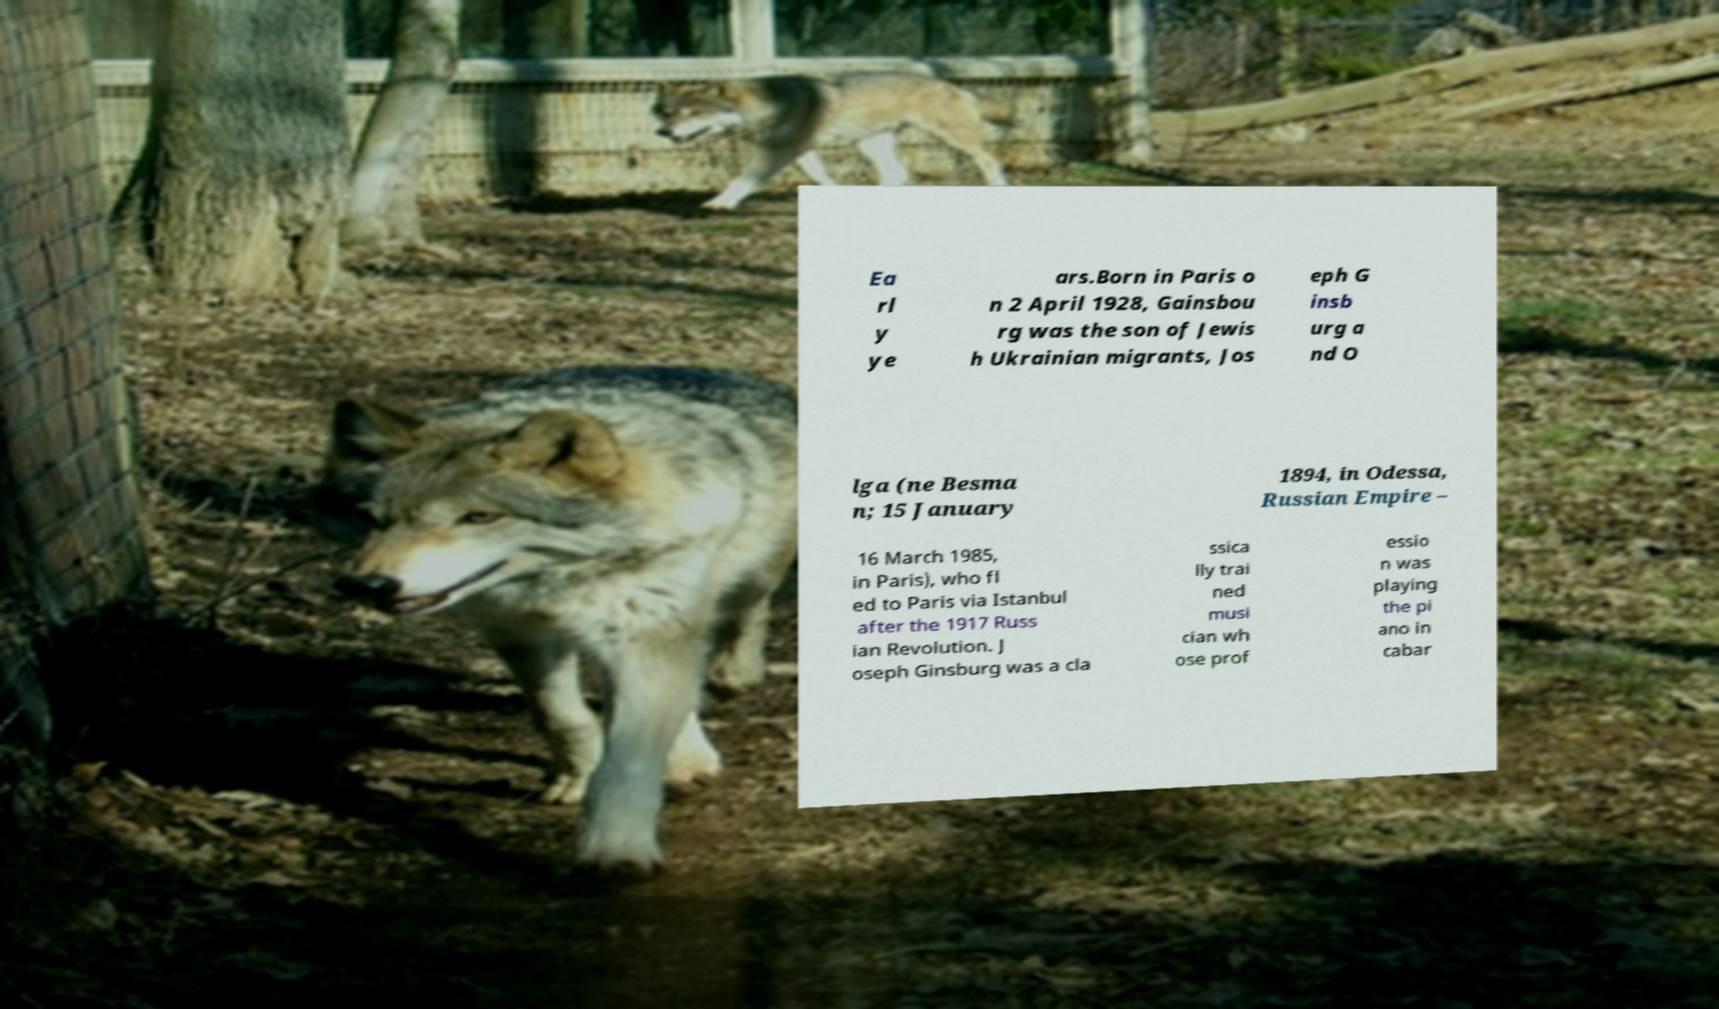Could you extract and type out the text from this image? Ea rl y ye ars.Born in Paris o n 2 April 1928, Gainsbou rg was the son of Jewis h Ukrainian migrants, Jos eph G insb urg a nd O lga (ne Besma n; 15 January 1894, in Odessa, Russian Empire – 16 March 1985, in Paris), who fl ed to Paris via Istanbul after the 1917 Russ ian Revolution. J oseph Ginsburg was a cla ssica lly trai ned musi cian wh ose prof essio n was playing the pi ano in cabar 